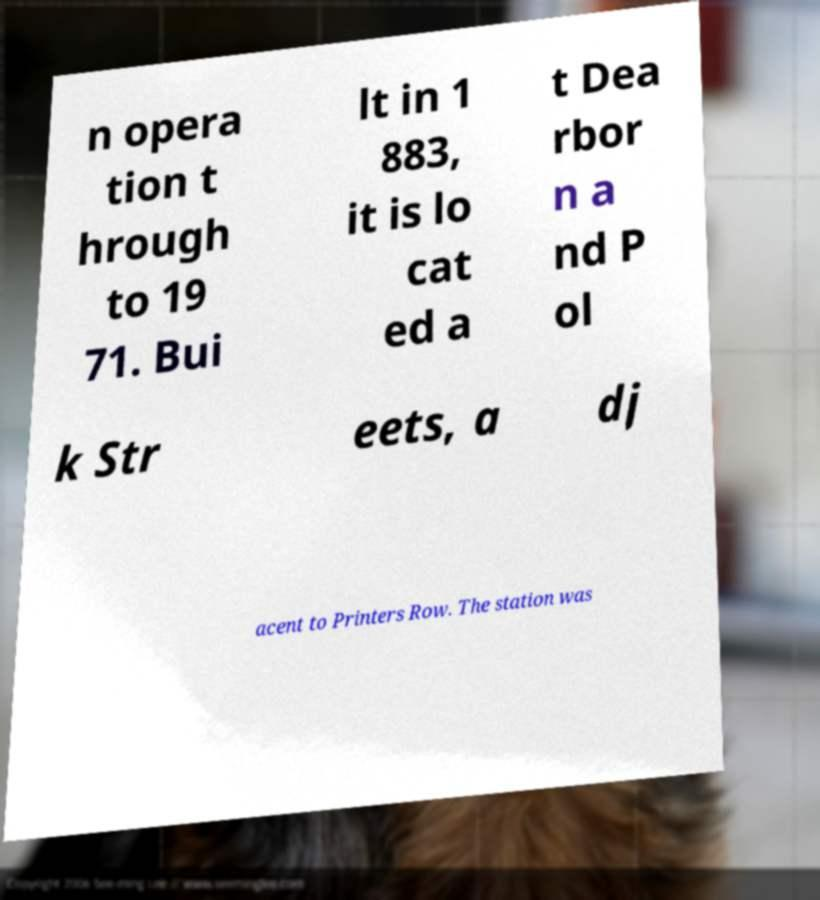Please read and relay the text visible in this image. What does it say? n opera tion t hrough to 19 71. Bui lt in 1 883, it is lo cat ed a t Dea rbor n a nd P ol k Str eets, a dj acent to Printers Row. The station was 